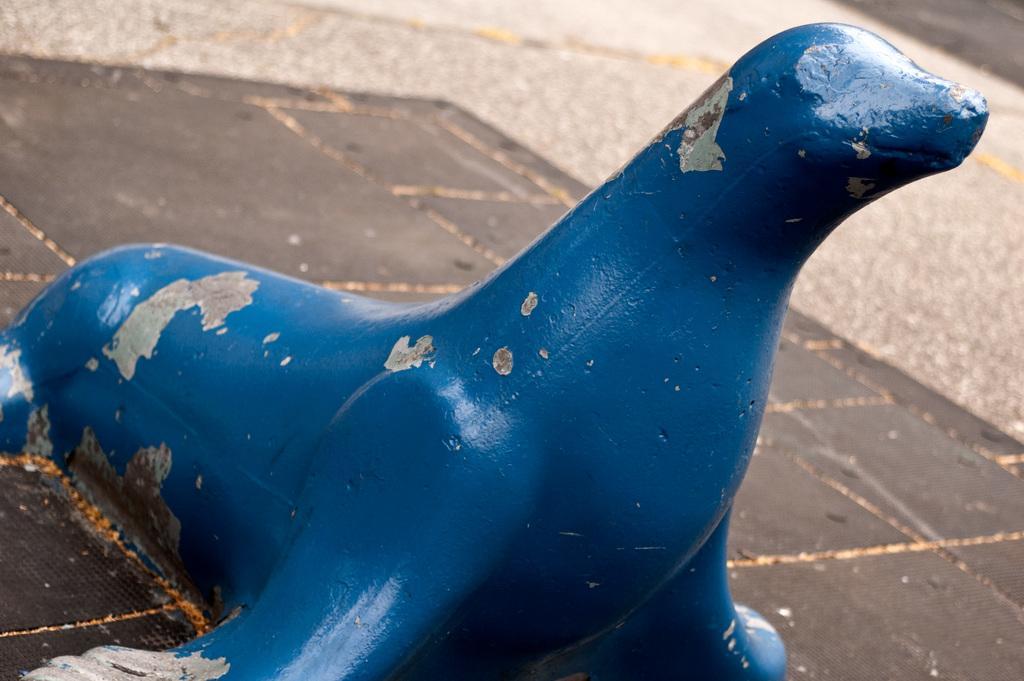Describe this image in one or two sentences. In the picture we can see a path with tiles on it we can see a sea lion which is blue in color. 